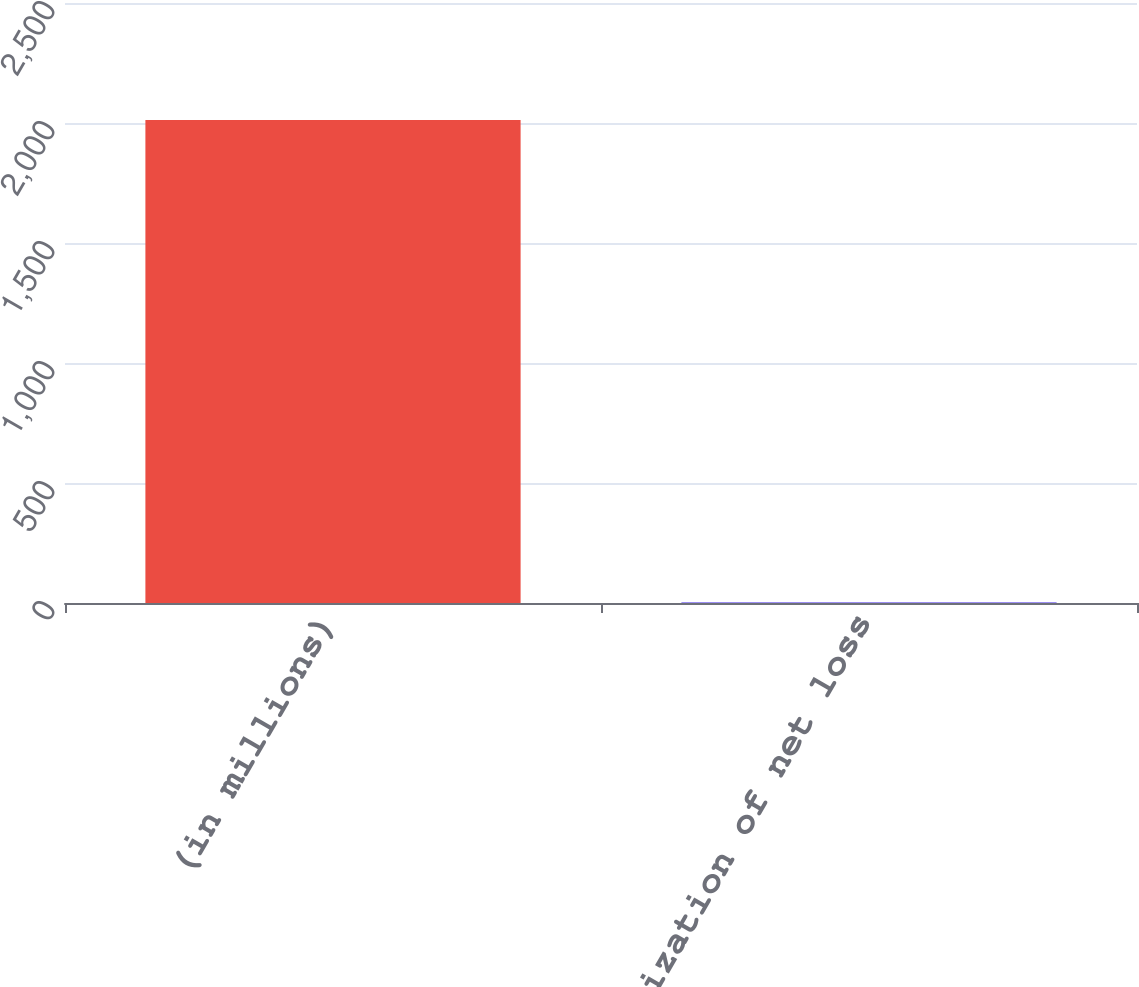Convert chart. <chart><loc_0><loc_0><loc_500><loc_500><bar_chart><fcel>(in millions)<fcel>Amortization of net loss<nl><fcel>2013<fcel>3<nl></chart> 